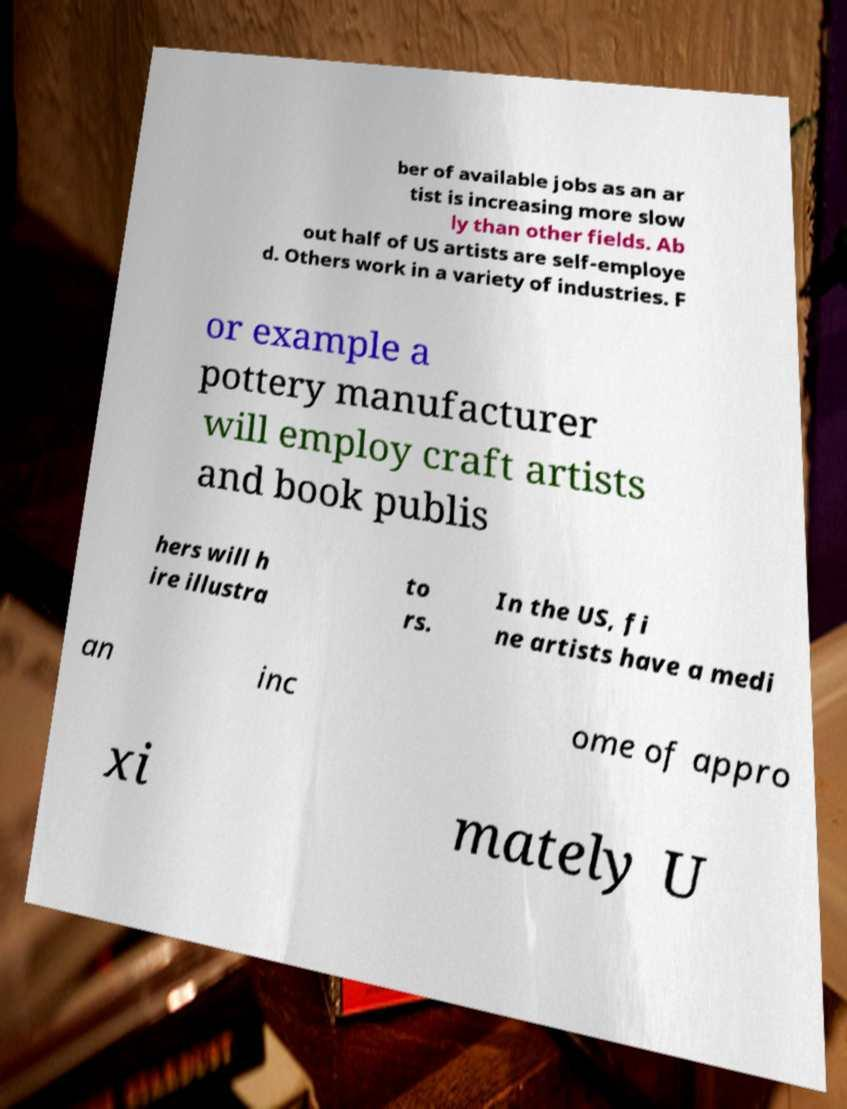Please read and relay the text visible in this image. What does it say? ber of available jobs as an ar tist is increasing more slow ly than other fields. Ab out half of US artists are self-employe d. Others work in a variety of industries. F or example a pottery manufacturer will employ craft artists and book publis hers will h ire illustra to rs. In the US, fi ne artists have a medi an inc ome of appro xi mately U 